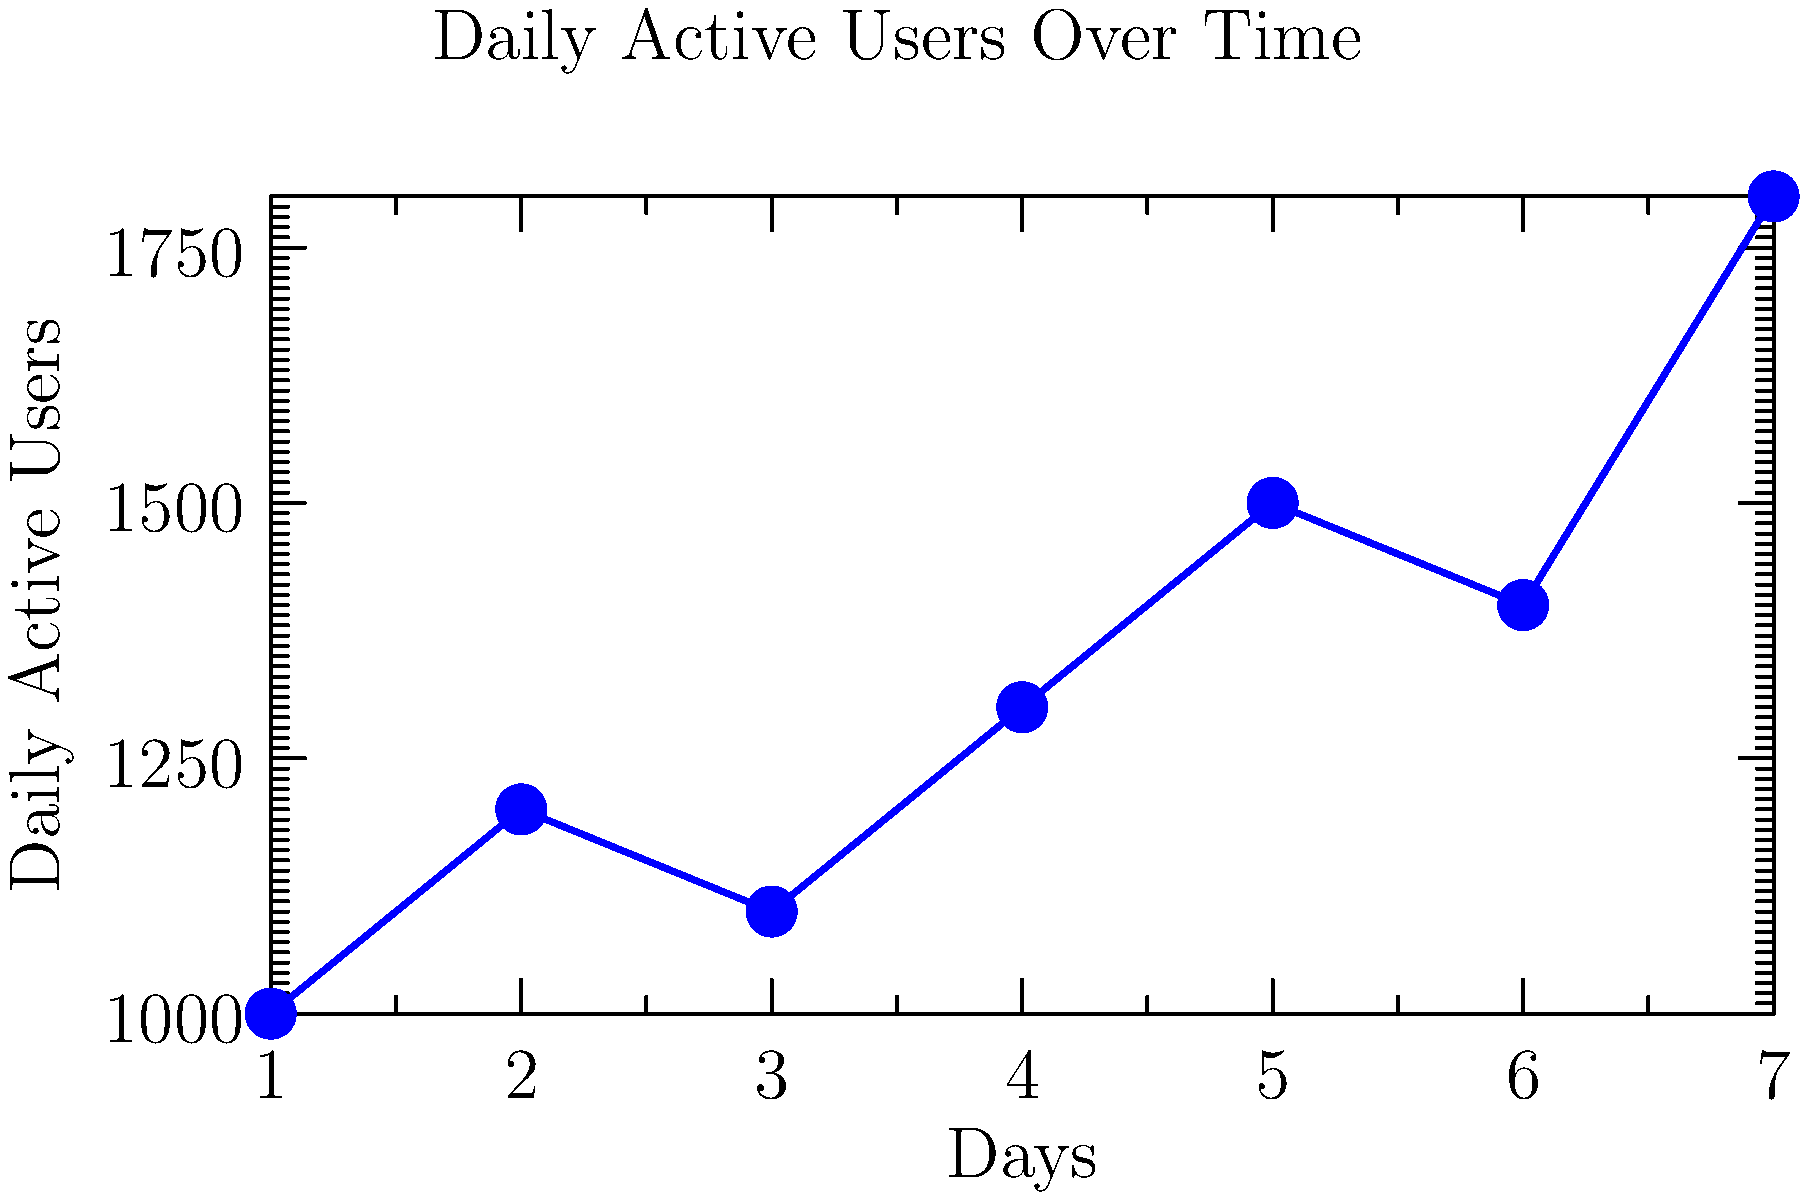As a product manager, you're analyzing the line graph showing daily active users over a week. What key insight about user engagement can you derive from the overall trend, and how might this inform your product development strategy? To answer this question, let's analyze the graph step-by-step:

1. Observe the overall trend: The line graph shows an general upward trend in daily active users over the week.

2. Calculate the growth:
   - Starting point (Day 1): 1000 users
   - Ending point (Day 7): 1800 users
   - Overall growth: $(1800 - 1000) / 1000 \times 100\% = 80\%$ increase

3. Analyze fluctuations:
   - There are some day-to-day fluctuations, but the overall trend is positive.
   - The largest single-day increase is from Day 6 to Day 7.

4. Interpret the data:
   - The consistent upward trend suggests that user engagement is growing steadily.
   - The fluctuations indicate that there might be factors affecting daily usage (e.g., weekday vs. weekend patterns).

5. Product development implications:
   - The growing user base suggests that the current features are attracting and retaining users.
   - The strong finish to the week (Day 7) might indicate a particular feature or use case that's driving engagement.

Key insight: User engagement is growing steadily, with an 80% increase over the week, suggesting that current features are effective but there's potential for further growth.

Product development strategy:
   - Investigate the factors behind the Day 7 spike to potentially enhance or replicate those elements.
   - Focus on maintaining and improving features that are driving the overall growth trend.
   - Consider implementing analytics to understand the reasons for daily fluctuations and optimize accordingly.
Answer: Steady growth in user engagement (80% increase) suggests effective features; focus on replicating Day 7 success and understanding daily fluctuations. 